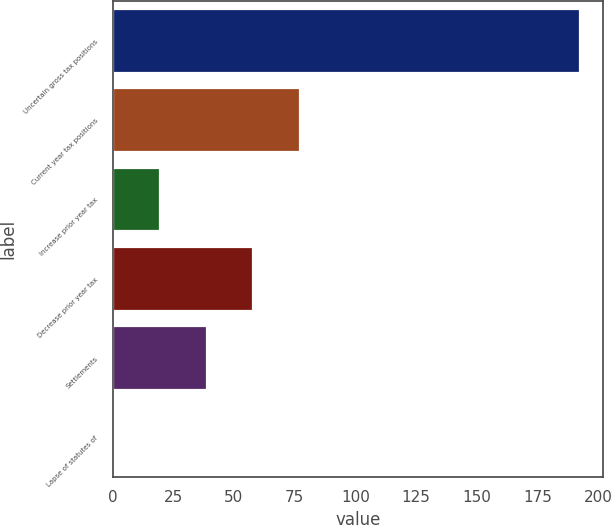<chart> <loc_0><loc_0><loc_500><loc_500><bar_chart><fcel>Uncertain gross tax positions<fcel>Current year tax positions<fcel>Increase prior year tax<fcel>Decrease prior year tax<fcel>Settlements<fcel>Lapse of statutes of<nl><fcel>192.3<fcel>77.16<fcel>19.59<fcel>57.97<fcel>38.78<fcel>0.4<nl></chart> 